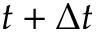<formula> <loc_0><loc_0><loc_500><loc_500>t + \Delta t</formula> 